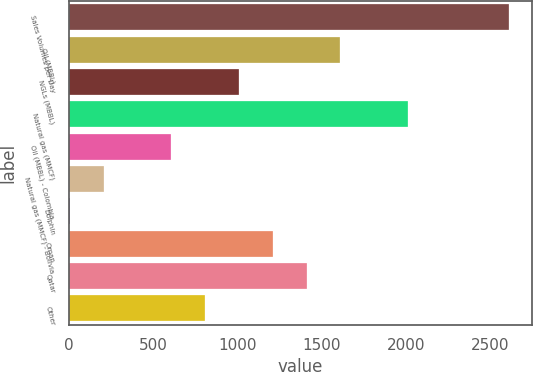Convert chart. <chart><loc_0><loc_0><loc_500><loc_500><bar_chart><fcel>Sales Volumes per Day<fcel>Oil (MBBL)<fcel>NGLs (MBBL)<fcel>Natural gas (MMCF)<fcel>Oil (MBBL) - Colombia<fcel>Natural gas (MMCF) - Bolivia<fcel>Dolphin<fcel>Oman<fcel>Qatar<fcel>Other<nl><fcel>2613.2<fcel>1611.2<fcel>1010<fcel>2012<fcel>609.2<fcel>208.4<fcel>8<fcel>1210.4<fcel>1410.8<fcel>809.6<nl></chart> 